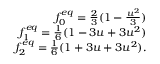Convert formula to latex. <formula><loc_0><loc_0><loc_500><loc_500>\begin{array} { r } { f _ { 0 } ^ { e q } = \frac { 2 } { 3 } ( 1 - \frac { u ^ { 2 } } { 3 } ) } \\ { f _ { 1 } ^ { e q } = \frac { 1 } { 6 } ( 1 - 3 u + 3 u ^ { 2 } ) } \\ { f _ { 2 } ^ { e q } = \frac { 1 } { 6 } ( 1 + 3 u + 3 u ^ { 2 } ) . } \end{array}</formula> 